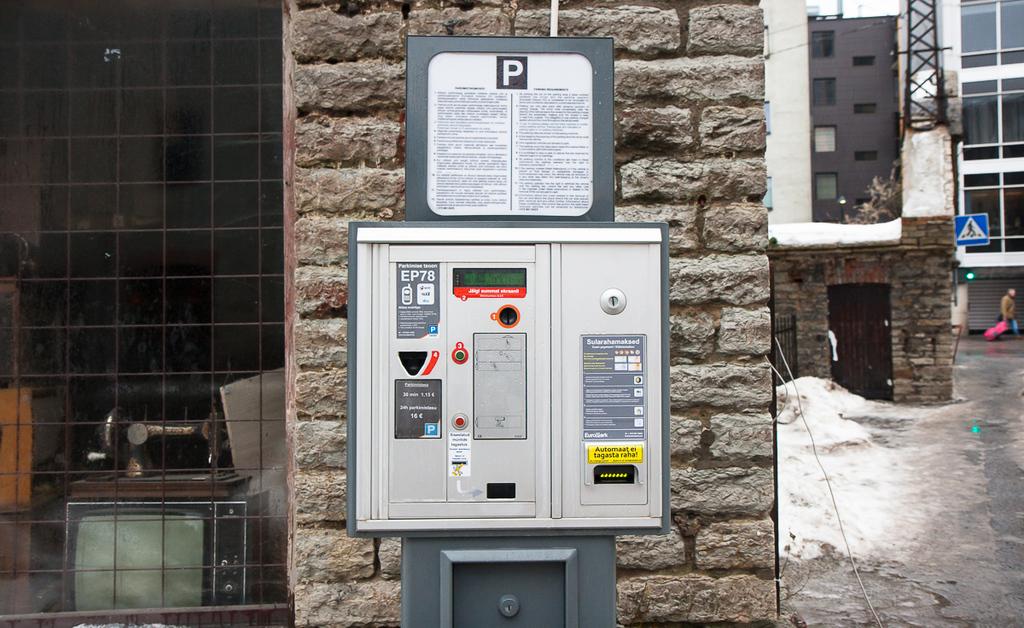What letters come before 78?
Your response must be concise. Ep. 